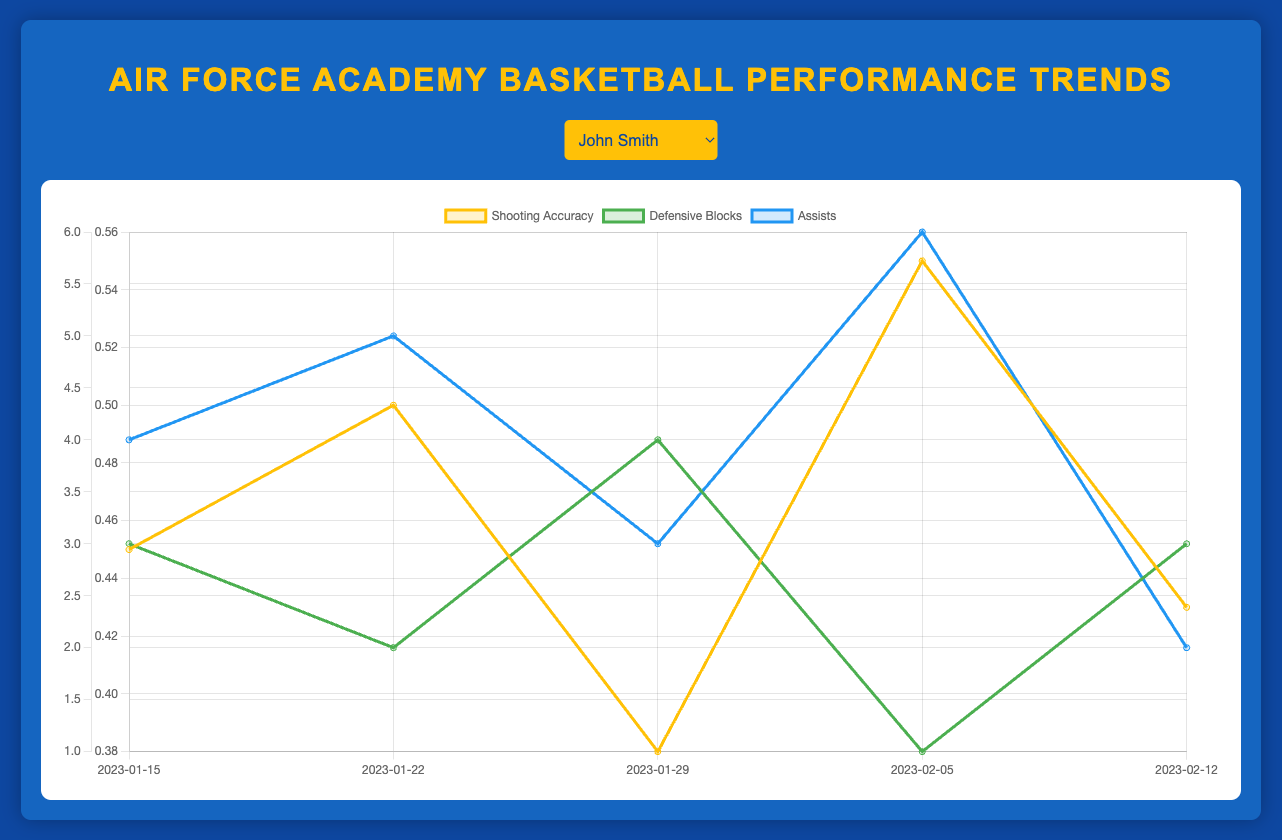What is the average shooting accuracy for Robert Johnson over the five games? To find the average shooting accuracy, we sum the shooting accuracy values for Robert Johnson over the five games (0.60 + 0.65 + 0.59 + 0.62 + 0.53) and then divide by the number of games (5). The sum is 2.99, and dividing by 5 gives us an average of 0.598.
Answer: 0.598 Between John Smith and Michael Lee, who had more assists in Game 3, and by how much? Checking the assists for Game 3, John Smith had 3 assists and Michael Lee had 6 assists. We subtract John Smith's assists from Michael Lee's assists (6 - 3) to find that Michael Lee had 3 more assists in Game 3.
Answer: Michael Lee, 3 more assists How did David Harris' shooting accuracy change from Game 2 to Game 4? To determine the change in David Harris' shooting accuracy, we take the shooting accuracy for Game 4 (0.48) and subtract the accuracy for Game 2 (0.40), which gives us a change of 0.08.
Answer: Increased by 0.08 Who had the highest shooting accuracy in Game 1 among all players, and what was the value? For Game 1, we compare the shooting accuracy among all players. John Smith had 0.45, Robert Johnson had 0.60, Michael Lee had 0.48, and David Harris had 0.42. The highest value is 0.60 by Robert Johnson.
Answer: Robert Johnson, 0.60 What trend can be observed in Michael Lee's assists over the season? Observing Michael Lee's assists over five games, the pattern is as follows: 5, 7, 6, 8, 7. The assists are increasing from Game 1 (5) to Game 4 (8), and then a slight decrease to 7 in Game 5, showing a generally increasing trend with some fluctuations.
Answer: Overall increasing trend with fluctuations Compare the total number of defensive blocks between John Smith and David Harris over the five games. Who had more and by how much? Summing the defensive blocks over the five games, John Smith had 3 + 2 + 4 + 1 + 3 = 13 blocks, and David Harris had 2 + 3 + 5 + 1 + 4 = 15 blocks. David Harris had 2 more blocks than John Smith (15 - 13 = 2).
Answer: David Harris, 2 more How consistent was John Smith's shooting accuracy compared to Robert Johnson's shooting accuracy? Reviewing the variations in shooting accuracy, John Smith's values were (0.45, 0.50, 0.38, 0.55, 0.43) with a range of (0.55-0.38) = 0.17, and Robert Johnson's values were (0.60, 0.65, 0.59, 0.62, 0.53) with a range of (0.65-0.53) = 0.12. Robert Johnson showed more consistency with a smaller range.
Answer: Robert Johnson, more consistent What is the average number of assists for Michael Lee over the entire season? Summing Michael Lee's assists (5 + 7 + 6 + 8 + 7 = 33) over five games, and then dividing by the number of games (5), gives an average of 33/5 = 6.6.
Answer: 6.6 Which visual attribute displays a significantly different range between two specific metrics of John Smith and what is the observed range difference? Analyzing the visual attributes, John Smith’s shooting accuracy ranged from 0.38 to 0.55, a range of 0.17. His defensive blocks ranged from 1 to 4, a range of 3. Comparing the two, the defensive blocks show a significantly larger range difference (3 vs. 0.17).
Answer: Defensive blocks, difference of 2.83 Based on the data, who appears to be the most versatile player in terms of contributing across shooting accuracy, defensive blocks, and assists? Michael Lee shows steady performance across shooting accuracy (0.48 to 0.52), assists (5 to 8), and defensive blocks (1 to 3). His contribution is consistent in all three categories, indicating versatility.
Answer: Michael Lee 